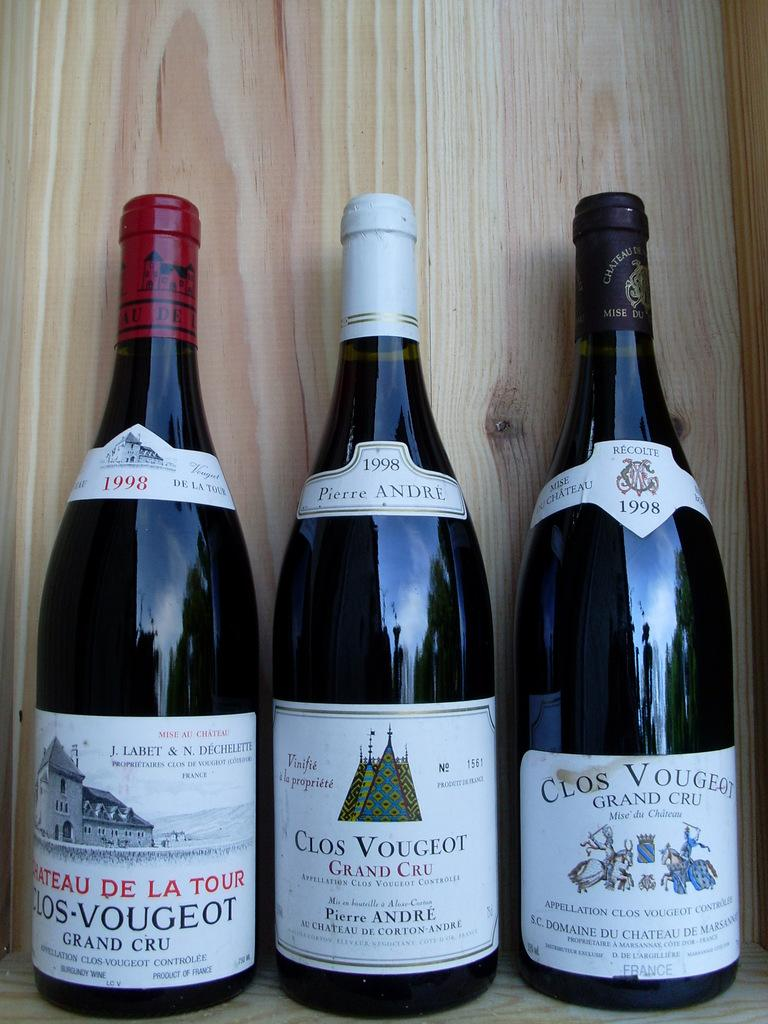<image>
Describe the image concisely. Three bottles of Clos Vougeot wine sit on a shelf. 